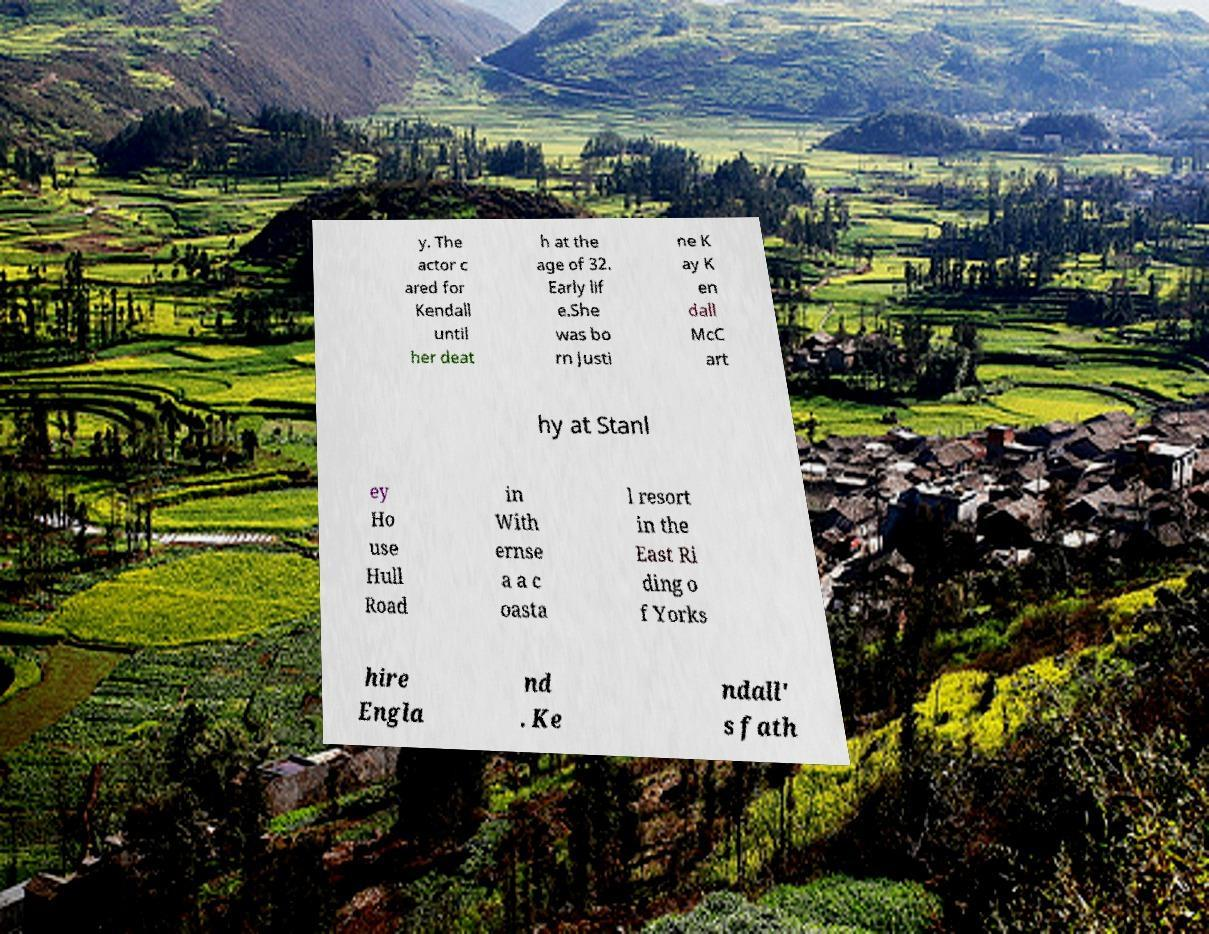Could you extract and type out the text from this image? y. The actor c ared for Kendall until her deat h at the age of 32. Early lif e.She was bo rn Justi ne K ay K en dall McC art hy at Stanl ey Ho use Hull Road in With ernse a a c oasta l resort in the East Ri ding o f Yorks hire Engla nd . Ke ndall' s fath 